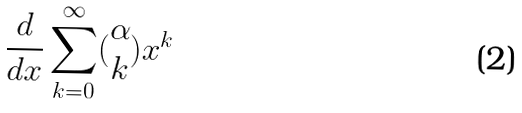Convert formula to latex. <formula><loc_0><loc_0><loc_500><loc_500>\frac { d } { d x } \sum _ { k = 0 } ^ { \infty } ( \begin{matrix} \alpha \\ k \end{matrix} ) x ^ { k }</formula> 